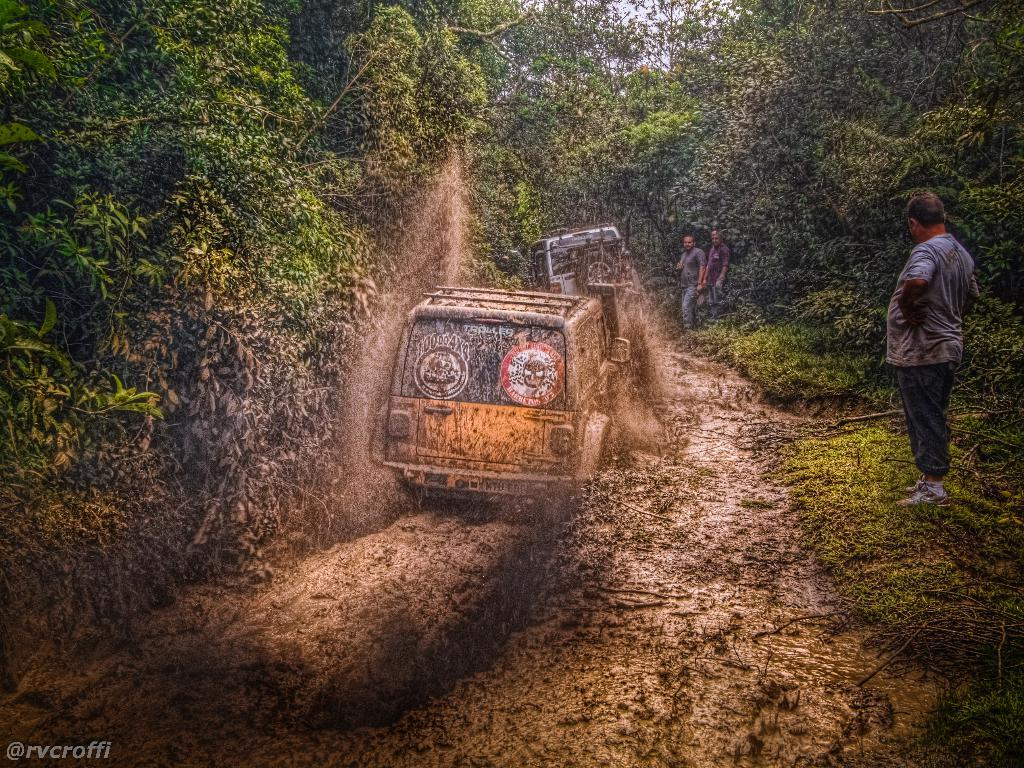What is the main subject of the image? There is a vehicle in the image. Can you describe the position of the vehicle? The vehicle is on the ground. How many people are visible in the image? There are three men standing on the right side of the image. What can be seen in the background of the image? There are many trees in the background of the image. What type of bushes can be seen growing on the wall in the image? There is no wall or bushes present in the image; it features a vehicle, three men, and many trees in the background. 